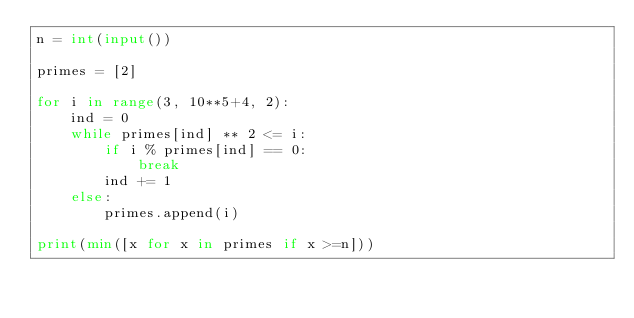Convert code to text. <code><loc_0><loc_0><loc_500><loc_500><_Python_>n = int(input())

primes = [2]

for i in range(3, 10**5+4, 2):
    ind = 0
    while primes[ind] ** 2 <= i:
        if i % primes[ind] == 0:
            break
        ind += 1
    else:
        primes.append(i)
        
print(min([x for x in primes if x >=n]))</code> 